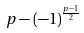<formula> <loc_0><loc_0><loc_500><loc_500>p - ( - 1 ) ^ { \frac { p - 1 } { 2 } }</formula> 